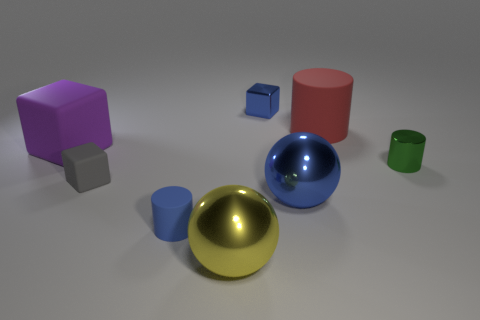Can you describe the lighting in this scene and how it affects the appearance of the objects? The scene is lit with soft, diffused lighting that casts gentle shadows to the right side of the objects, suggesting a light source coming from the left. This lighting emphasizes the texture differences, such as the matte finish of the gray cube and the shiny surfaces of the blue cylinder and golden sphere. 